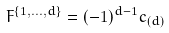<formula> <loc_0><loc_0><loc_500><loc_500>F ^ { \{ 1 , \dots , d \} } = ( - 1 ) ^ { d - 1 } c _ { ( d ) }</formula> 